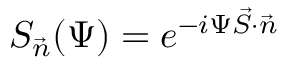Convert formula to latex. <formula><loc_0><loc_0><loc_500><loc_500>S _ { \vec { n } } ( \Psi ) = e ^ { - i \Psi \vec { S } \cdot \vec { n } }</formula> 